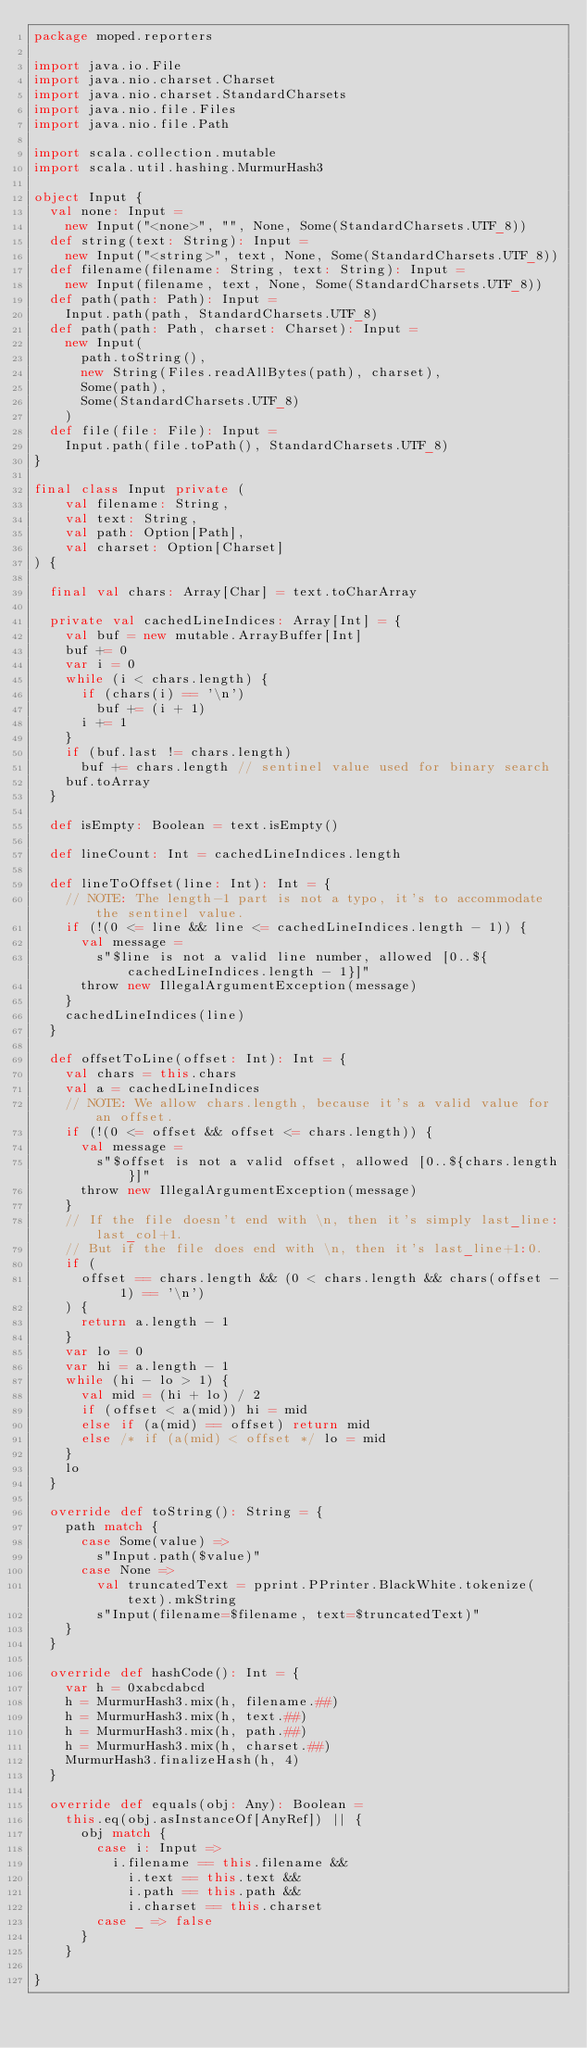Convert code to text. <code><loc_0><loc_0><loc_500><loc_500><_Scala_>package moped.reporters

import java.io.File
import java.nio.charset.Charset
import java.nio.charset.StandardCharsets
import java.nio.file.Files
import java.nio.file.Path

import scala.collection.mutable
import scala.util.hashing.MurmurHash3

object Input {
  val none: Input =
    new Input("<none>", "", None, Some(StandardCharsets.UTF_8))
  def string(text: String): Input =
    new Input("<string>", text, None, Some(StandardCharsets.UTF_8))
  def filename(filename: String, text: String): Input =
    new Input(filename, text, None, Some(StandardCharsets.UTF_8))
  def path(path: Path): Input =
    Input.path(path, StandardCharsets.UTF_8)
  def path(path: Path, charset: Charset): Input =
    new Input(
      path.toString(),
      new String(Files.readAllBytes(path), charset),
      Some(path),
      Some(StandardCharsets.UTF_8)
    )
  def file(file: File): Input =
    Input.path(file.toPath(), StandardCharsets.UTF_8)
}

final class Input private (
    val filename: String,
    val text: String,
    val path: Option[Path],
    val charset: Option[Charset]
) {

  final val chars: Array[Char] = text.toCharArray

  private val cachedLineIndices: Array[Int] = {
    val buf = new mutable.ArrayBuffer[Int]
    buf += 0
    var i = 0
    while (i < chars.length) {
      if (chars(i) == '\n')
        buf += (i + 1)
      i += 1
    }
    if (buf.last != chars.length)
      buf += chars.length // sentinel value used for binary search
    buf.toArray
  }

  def isEmpty: Boolean = text.isEmpty()

  def lineCount: Int = cachedLineIndices.length

  def lineToOffset(line: Int): Int = {
    // NOTE: The length-1 part is not a typo, it's to accommodate the sentinel value.
    if (!(0 <= line && line <= cachedLineIndices.length - 1)) {
      val message =
        s"$line is not a valid line number, allowed [0..${cachedLineIndices.length - 1}]"
      throw new IllegalArgumentException(message)
    }
    cachedLineIndices(line)
  }

  def offsetToLine(offset: Int): Int = {
    val chars = this.chars
    val a = cachedLineIndices
    // NOTE: We allow chars.length, because it's a valid value for an offset.
    if (!(0 <= offset && offset <= chars.length)) {
      val message =
        s"$offset is not a valid offset, allowed [0..${chars.length}]"
      throw new IllegalArgumentException(message)
    }
    // If the file doesn't end with \n, then it's simply last_line:last_col+1.
    // But if the file does end with \n, then it's last_line+1:0.
    if (
      offset == chars.length && (0 < chars.length && chars(offset - 1) == '\n')
    ) {
      return a.length - 1
    }
    var lo = 0
    var hi = a.length - 1
    while (hi - lo > 1) {
      val mid = (hi + lo) / 2
      if (offset < a(mid)) hi = mid
      else if (a(mid) == offset) return mid
      else /* if (a(mid) < offset */ lo = mid
    }
    lo
  }

  override def toString(): String = {
    path match {
      case Some(value) =>
        s"Input.path($value)"
      case None =>
        val truncatedText = pprint.PPrinter.BlackWhite.tokenize(text).mkString
        s"Input(filename=$filename, text=$truncatedText)"
    }
  }

  override def hashCode(): Int = {
    var h = 0xabcdabcd
    h = MurmurHash3.mix(h, filename.##)
    h = MurmurHash3.mix(h, text.##)
    h = MurmurHash3.mix(h, path.##)
    h = MurmurHash3.mix(h, charset.##)
    MurmurHash3.finalizeHash(h, 4)
  }

  override def equals(obj: Any): Boolean =
    this.eq(obj.asInstanceOf[AnyRef]) || {
      obj match {
        case i: Input =>
          i.filename == this.filename &&
            i.text == this.text &&
            i.path == this.path &&
            i.charset == this.charset
        case _ => false
      }
    }

}
</code> 